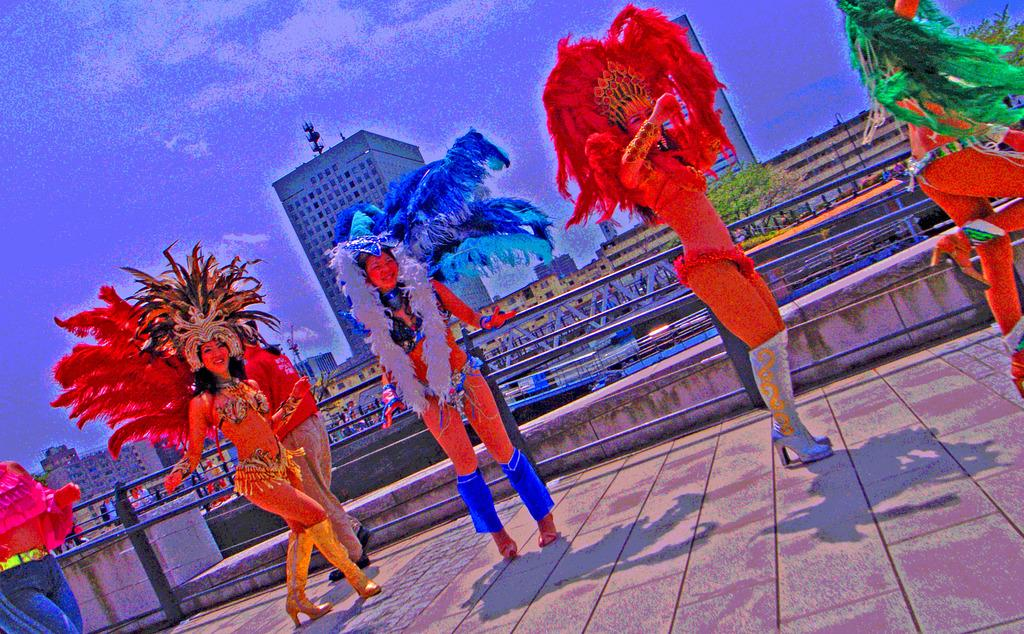Who is present in the image? There are women in the image. What are the women wearing? The women are wearing fancy dresses. What are the women doing in the image? The women are dancing. What can be seen in the background of the image? There are buildings in the background of the image. Are there any snakes visible in the image? No, there are no snakes present in the image. What process is being followed by the women in the image? The provided facts do not mention any specific process being followed by the women; they are simply dancing. 